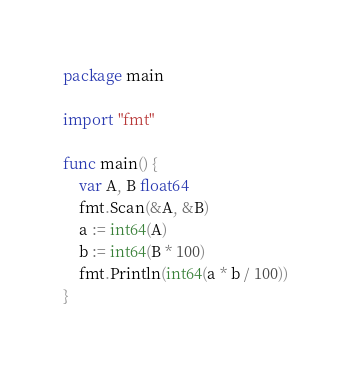Convert code to text. <code><loc_0><loc_0><loc_500><loc_500><_Go_>package main

import "fmt"

func main() {
	var A, B float64
	fmt.Scan(&A, &B)
	a := int64(A)
	b := int64(B * 100)
	fmt.Println(int64(a * b / 100))
}
</code> 